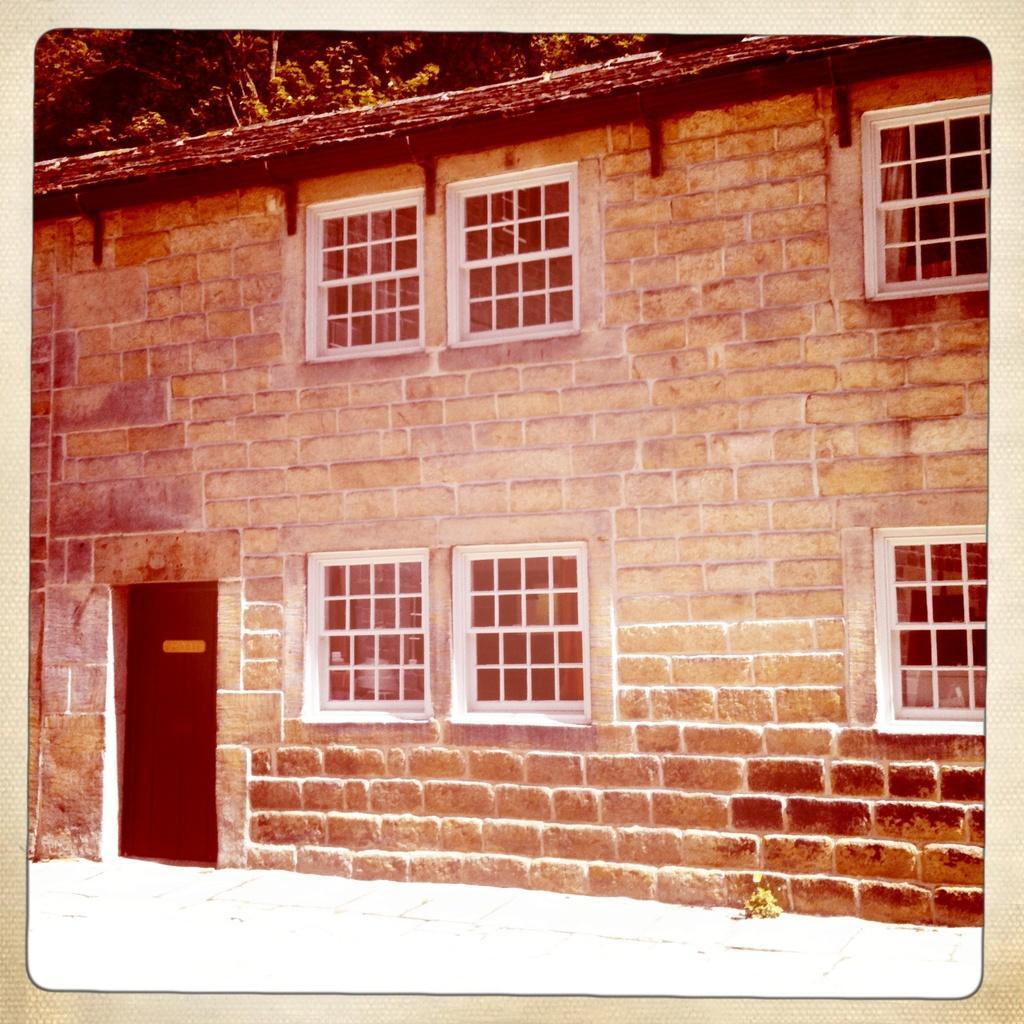In one or two sentences, can you explain what this image depicts? In this picture we can see the old image of the brown brick wall and white window glass. 